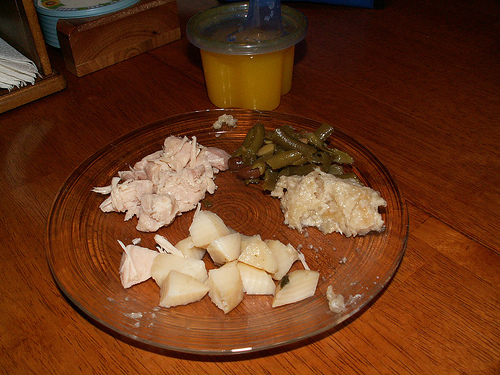<image>
Can you confirm if the pepper is on the glass? Yes. Looking at the image, I can see the pepper is positioned on top of the glass, with the glass providing support. 